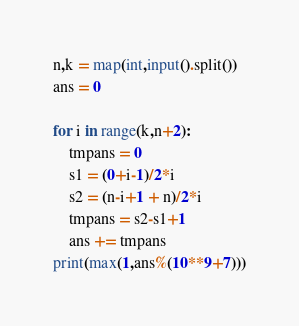<code> <loc_0><loc_0><loc_500><loc_500><_Python_>n,k = map(int,input().split())
ans = 0

for i in range(k,n+2):
    tmpans = 0
    s1 = (0+i-1)/2*i
    s2 = (n-i+1 + n)/2*i
    tmpans = s2-s1+1
    ans += tmpans
print(max(1,ans%(10**9+7)))</code> 